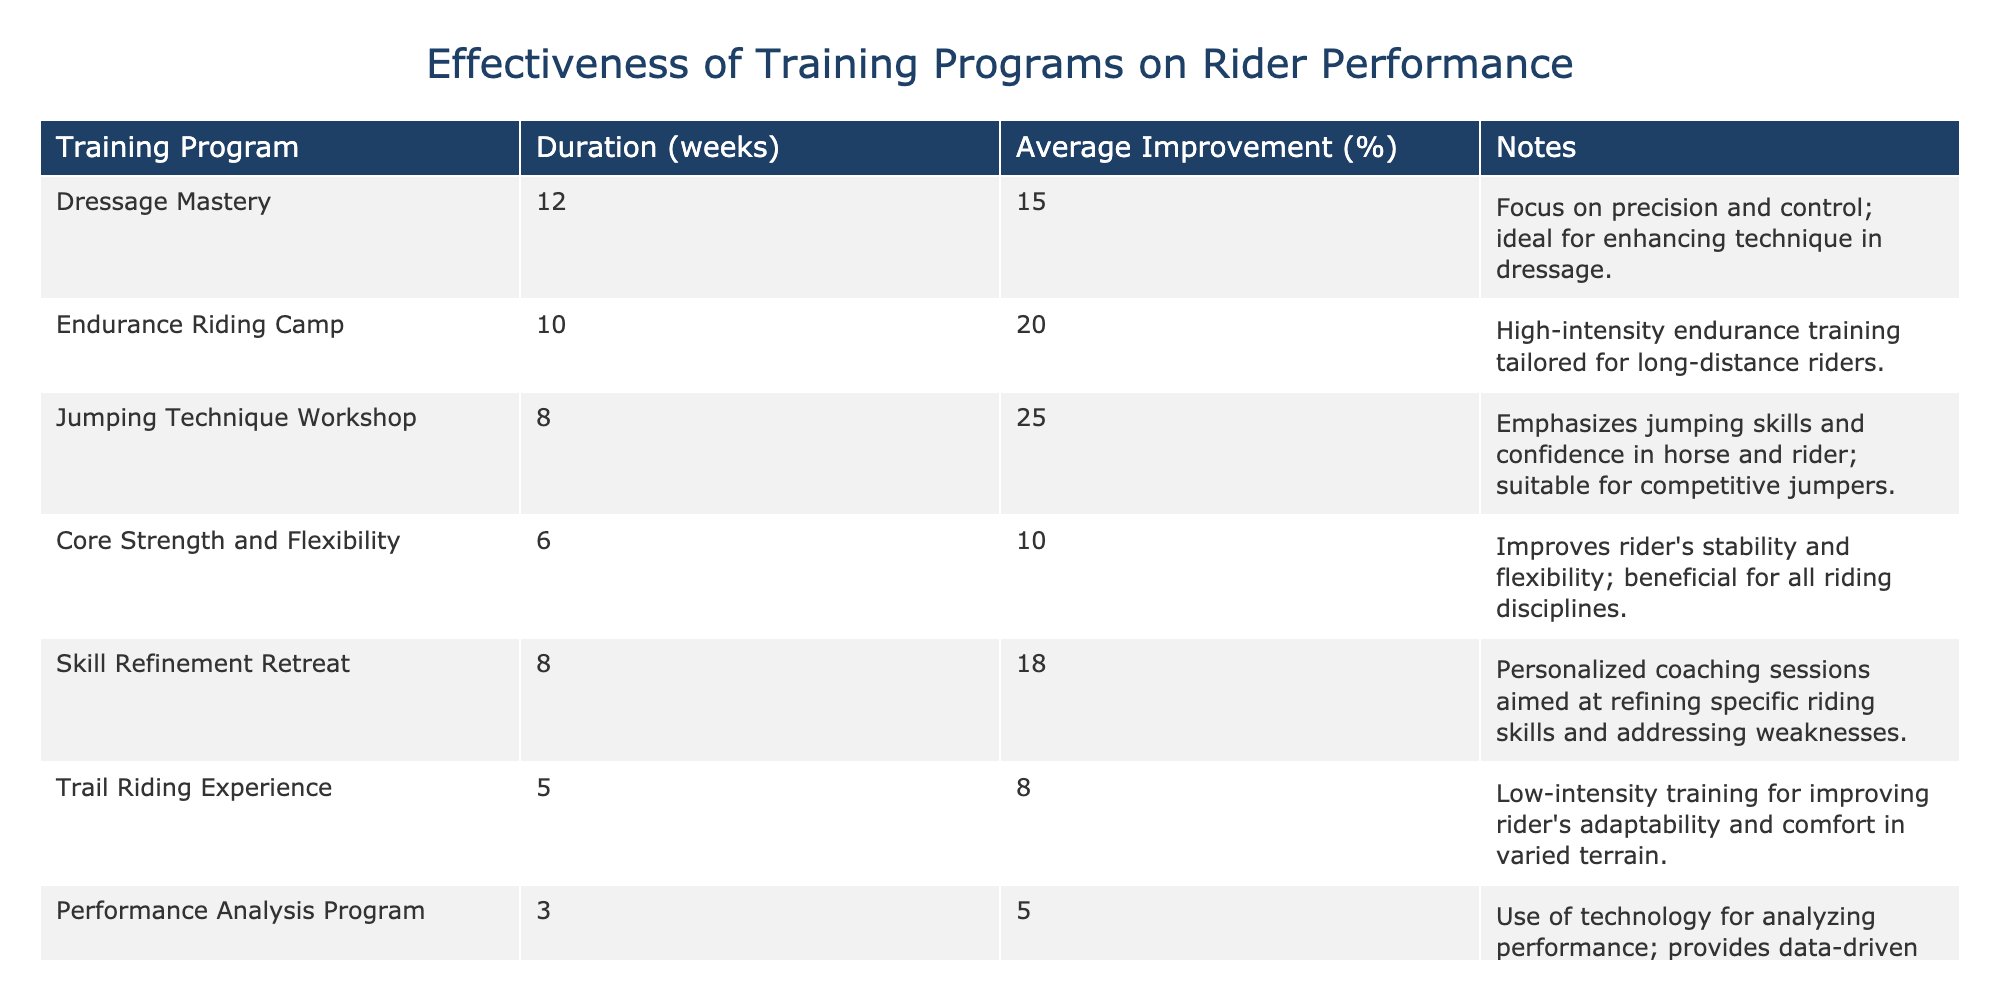What is the training program with the highest average improvement percentage? The table shows that the "Jumping Technique Workshop" has the highest average improvement percentage at 25%. This is directly listed in the "Average Improvement (%)" column corresponding to that training program.
Answer: Jumping Technique Workshop How long is the "Dressage Mastery" program? The "Dressage Mastery" program has a duration of 12 weeks, which can be found in the "Duration (weeks)" column next to the program's name.
Answer: 12 weeks What is the average improvement percentage of the "Core Strength and Flexibility" program? According to the table, the "Core Strength and Flexibility" program shows an average improvement percentage of 10%. This percentage is stated clearly in the "Average Improvement (%)" column for that program.
Answer: 10% Which program focuses on long-distance riders? The "Endurance Riding Camp" focuses on long-distance riders, as specified in the notes for that training program. The description explicitly mentions that it is high-intensity endurance training tailored for that purpose.
Answer: Endurance Riding Camp Is the average improvement percentage for "Trail Riding Experience" greater than 10%? The "Trail Riding Experience" has an average improvement percentage of 8%, which is less than 10%. This can be confirmed by looking at the "Average Improvement (%)" column for that program.
Answer: No What is the total average improvement percentage of all listed training programs? To find the total average improvement percentage, we sum the improvements of all listed programs: 15 + 20 + 25 + 10 + 18 + 8 + 5 = 101. There are 7 programs, so we divide the total by 7 to get the average: 101 / 7 ≈ 14.43%. This requires adding the averages and dividing by the number of programs.
Answer: Approximately 14.43% How does the "Performance Analysis Program" compare in duration to "Jumping Technique Workshop"? The "Performance Analysis Program" lasts for 3 weeks, while the "Jumping Technique Workshop" lasts for 8 weeks. Comparing these durations shows that the Performance Analysis Program is significantly shorter.
Answer: Shorter by 5 weeks Does any program have an average improvement percentage of over 20%? Yes, both the "Endurance Riding Camp" and the "Jumping Technique Workshop" have average improvement percentages of 20% and 25%, respectively. These values can be confirmed from the "Average Improvement (%)" column.
Answer: Yes What is the difference in average improvement percentage between the "Skill Refinement Retreat" and the "Core Strength and Flexibility" program? The "Skill Refinement Retreat" has an average improvement percentage of 18%, while the "Core Strength and Flexibility" program has 10%. The difference is 18 - 10 = 8%. Thus, we subtract the two percentages to find the difference.
Answer: 8% 